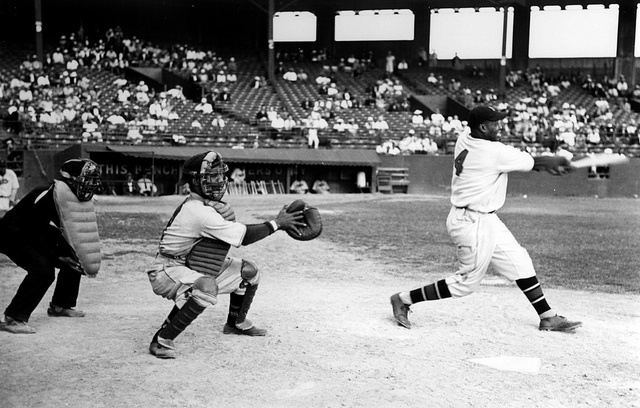Describe the objects in this image and their specific colors. I can see people in black, gray, darkgray, and lightgray tones, people in black, darkgray, gray, and lightgray tones, people in black, white, darkgray, and gray tones, people in black, gray, darkgray, and lightgray tones, and bench in black, gray, darkgray, and lightgray tones in this image. 